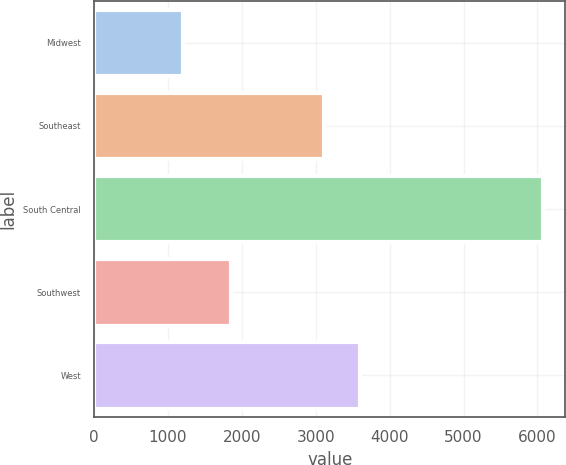<chart> <loc_0><loc_0><loc_500><loc_500><bar_chart><fcel>Midwest<fcel>Southeast<fcel>South Central<fcel>Southwest<fcel>West<nl><fcel>1198<fcel>3107<fcel>6074<fcel>1849<fcel>3594.6<nl></chart> 